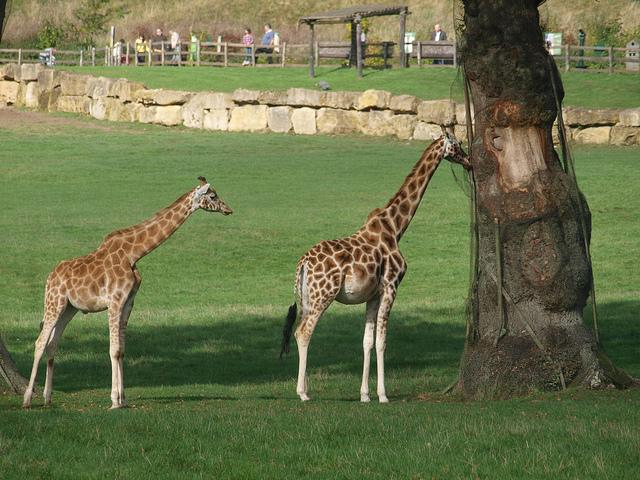How many giraffes are gathered around the tree with some mild damage? two 